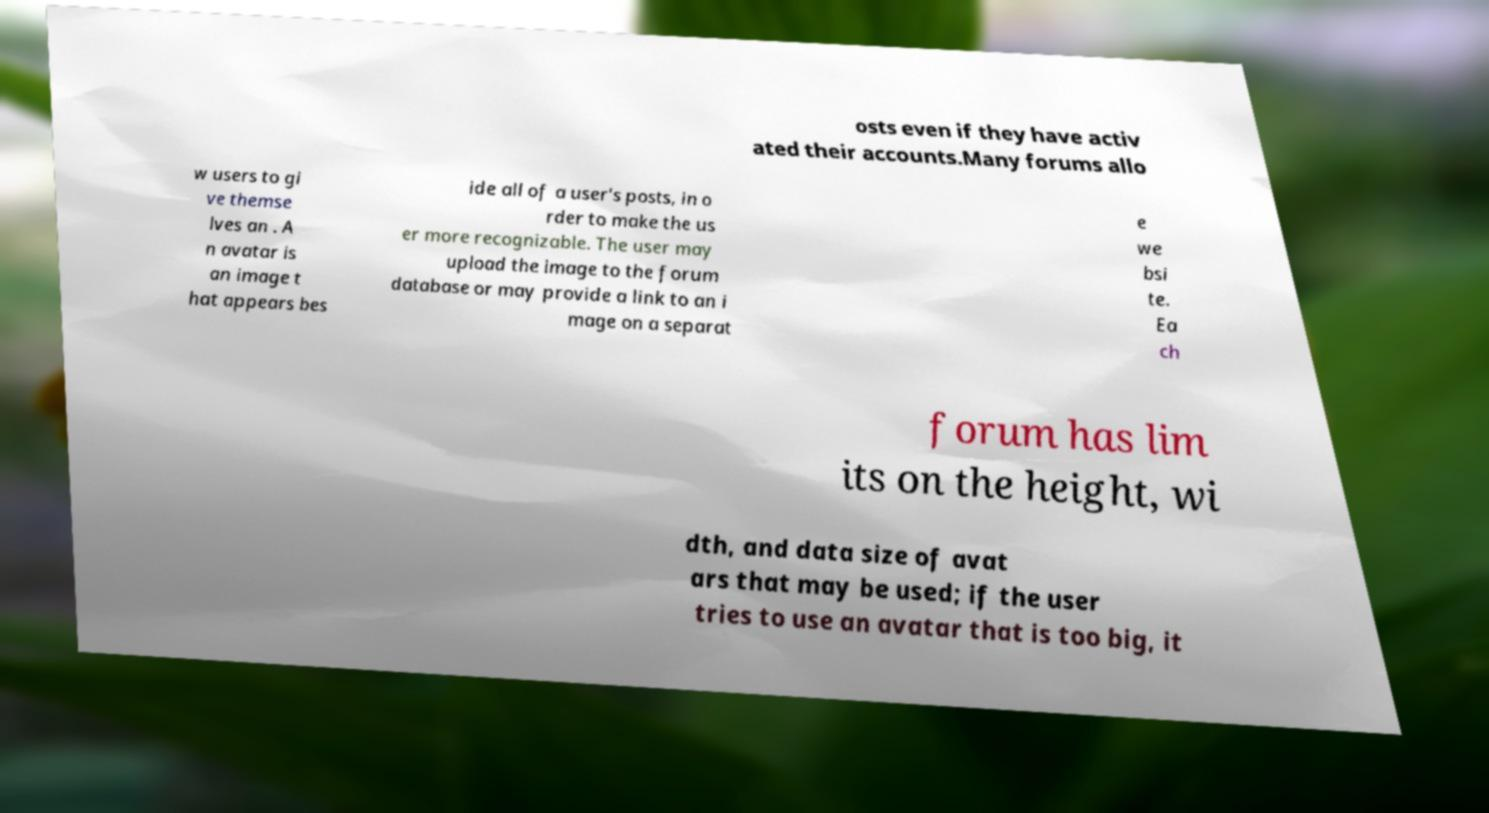Please identify and transcribe the text found in this image. osts even if they have activ ated their accounts.Many forums allo w users to gi ve themse lves an . A n avatar is an image t hat appears bes ide all of a user's posts, in o rder to make the us er more recognizable. The user may upload the image to the forum database or may provide a link to an i mage on a separat e we bsi te. Ea ch forum has lim its on the height, wi dth, and data size of avat ars that may be used; if the user tries to use an avatar that is too big, it 